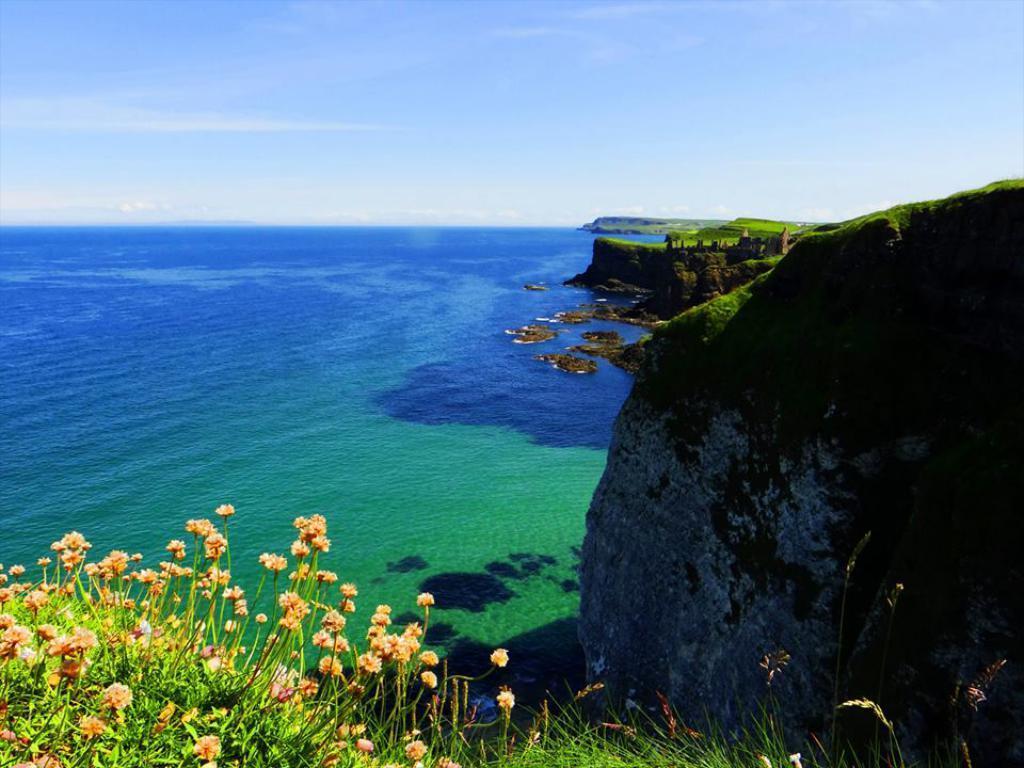Please provide a concise description of this image. Here we can see plants with flowers and this is water. In the background there is sky. 